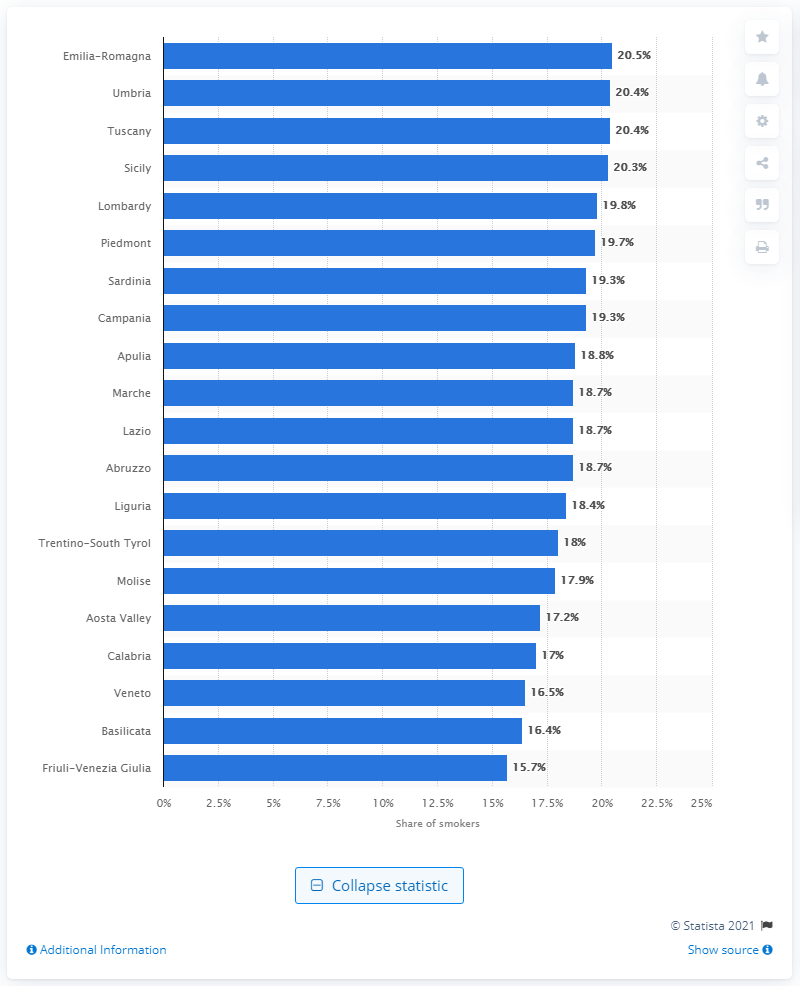Specify some key components in this picture. According to data, Emilia-Romagna had the highest percentage of smokers in Italy. Friuli-Venezia Giulia had the lowest percentage of smokers among all regions in Italy. 